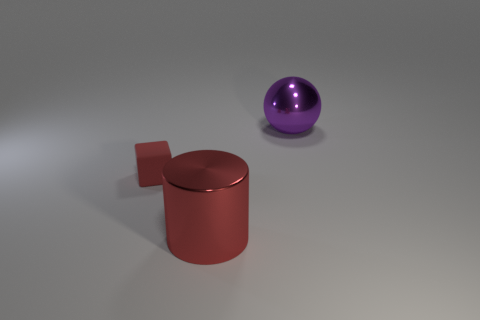Is there a cube that has the same size as the purple metallic thing?
Your answer should be compact. No. There is a thing that is both on the right side of the tiny red object and behind the large red cylinder; what is it made of?
Make the answer very short. Metal. What number of metal objects are big green blocks or red blocks?
Provide a succinct answer. 0. The other big object that is made of the same material as the purple thing is what shape?
Provide a short and direct response. Cylinder. What number of things are right of the small thing and behind the red metallic thing?
Keep it short and to the point. 1. Are there any other things that are the same shape as the red rubber thing?
Provide a succinct answer. No. There is a thing that is behind the red block; what is its size?
Make the answer very short. Large. How many other things are the same color as the metallic ball?
Your answer should be compact. 0. What is the material of the object that is behind the red thing on the left side of the cylinder?
Ensure brevity in your answer.  Metal. There is a thing that is to the left of the large red metal cylinder; is it the same color as the cylinder?
Make the answer very short. Yes. 